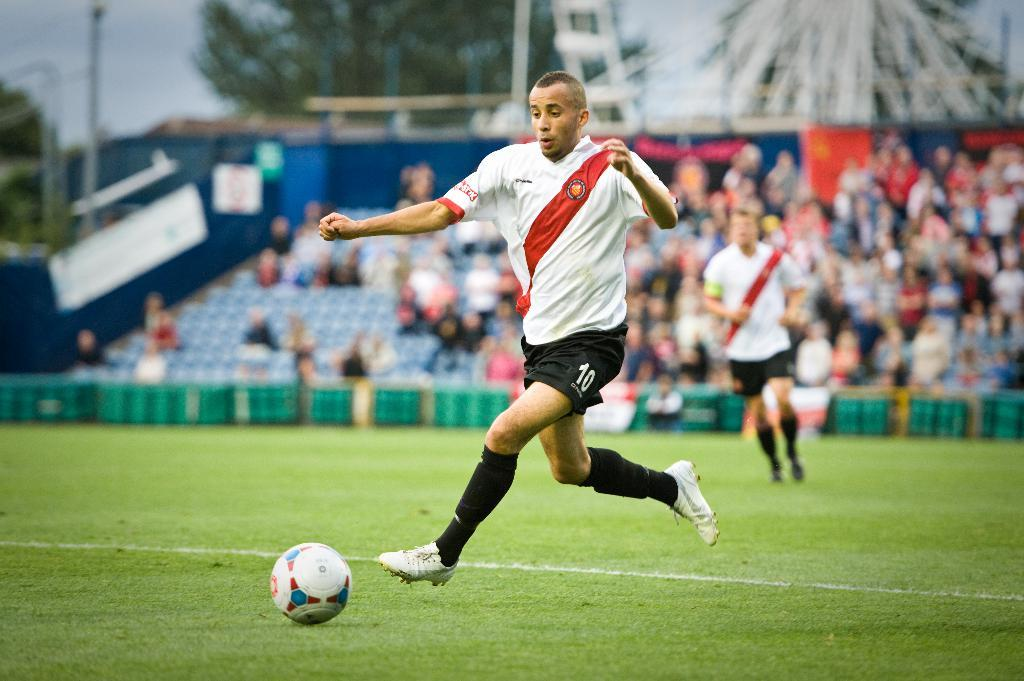<image>
Provide a brief description of the given image. Player number 10 wears black shorts and prepares to kick the soccer ball. 